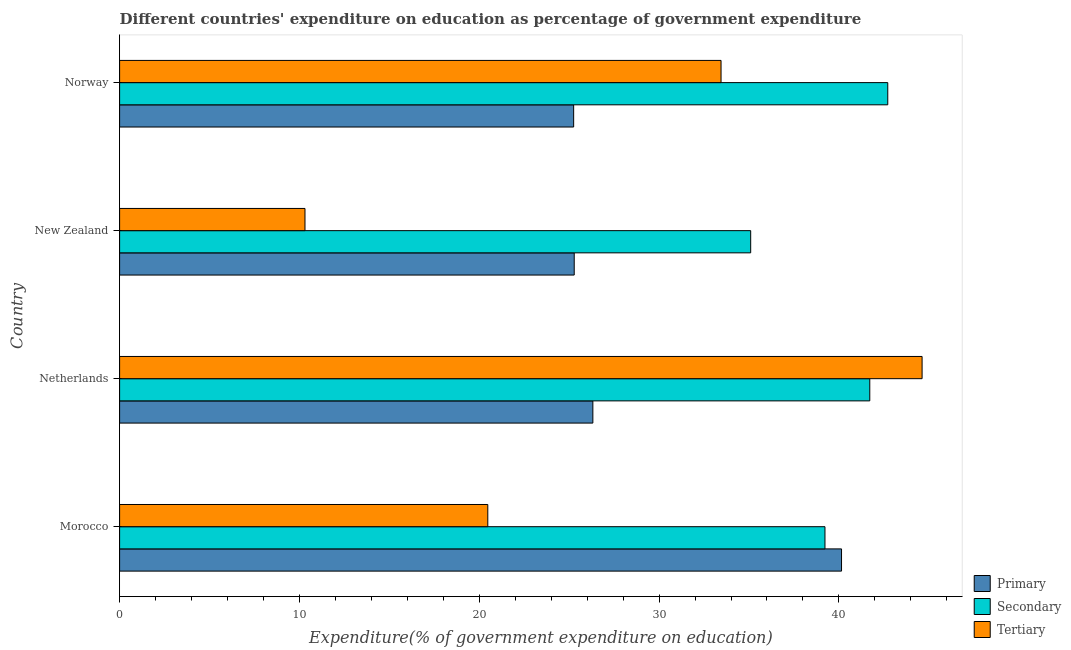How many different coloured bars are there?
Your answer should be compact. 3. Are the number of bars per tick equal to the number of legend labels?
Keep it short and to the point. Yes. Are the number of bars on each tick of the Y-axis equal?
Keep it short and to the point. Yes. How many bars are there on the 1st tick from the top?
Your answer should be very brief. 3. What is the label of the 2nd group of bars from the top?
Provide a succinct answer. New Zealand. What is the expenditure on tertiary education in Netherlands?
Provide a short and direct response. 44.63. Across all countries, what is the maximum expenditure on primary education?
Keep it short and to the point. 40.15. Across all countries, what is the minimum expenditure on tertiary education?
Your answer should be very brief. 10.31. In which country was the expenditure on tertiary education maximum?
Provide a succinct answer. Netherlands. In which country was the expenditure on secondary education minimum?
Keep it short and to the point. New Zealand. What is the total expenditure on tertiary education in the graph?
Ensure brevity in your answer.  108.85. What is the difference between the expenditure on primary education in Morocco and that in Norway?
Ensure brevity in your answer.  14.9. What is the difference between the expenditure on primary education in Morocco and the expenditure on secondary education in New Zealand?
Ensure brevity in your answer.  5.05. What is the average expenditure on secondary education per country?
Your response must be concise. 39.69. What is the difference between the expenditure on primary education and expenditure on tertiary education in New Zealand?
Make the answer very short. 14.97. In how many countries, is the expenditure on tertiary education greater than 10 %?
Your response must be concise. 4. What is the ratio of the expenditure on primary education in New Zealand to that in Norway?
Offer a very short reply. 1. Is the expenditure on tertiary education in Netherlands less than that in New Zealand?
Make the answer very short. No. Is the difference between the expenditure on secondary education in Netherlands and Norway greater than the difference between the expenditure on tertiary education in Netherlands and Norway?
Give a very brief answer. No. What is the difference between the highest and the second highest expenditure on tertiary education?
Give a very brief answer. 11.18. What is the difference between the highest and the lowest expenditure on primary education?
Your answer should be compact. 14.9. Is the sum of the expenditure on tertiary education in New Zealand and Norway greater than the maximum expenditure on secondary education across all countries?
Keep it short and to the point. Yes. What does the 2nd bar from the top in Norway represents?
Offer a very short reply. Secondary. What does the 2nd bar from the bottom in Morocco represents?
Your response must be concise. Secondary. How many countries are there in the graph?
Your answer should be very brief. 4. Does the graph contain any zero values?
Ensure brevity in your answer.  No. How many legend labels are there?
Keep it short and to the point. 3. What is the title of the graph?
Your response must be concise. Different countries' expenditure on education as percentage of government expenditure. Does "Total employers" appear as one of the legend labels in the graph?
Give a very brief answer. No. What is the label or title of the X-axis?
Your answer should be very brief. Expenditure(% of government expenditure on education). What is the Expenditure(% of government expenditure on education) in Primary in Morocco?
Keep it short and to the point. 40.15. What is the Expenditure(% of government expenditure on education) of Secondary in Morocco?
Give a very brief answer. 39.22. What is the Expenditure(% of government expenditure on education) in Tertiary in Morocco?
Your response must be concise. 20.47. What is the Expenditure(% of government expenditure on education) in Primary in Netherlands?
Give a very brief answer. 26.32. What is the Expenditure(% of government expenditure on education) in Secondary in Netherlands?
Offer a terse response. 41.72. What is the Expenditure(% of government expenditure on education) in Tertiary in Netherlands?
Make the answer very short. 44.63. What is the Expenditure(% of government expenditure on education) in Primary in New Zealand?
Offer a very short reply. 25.28. What is the Expenditure(% of government expenditure on education) of Secondary in New Zealand?
Keep it short and to the point. 35.09. What is the Expenditure(% of government expenditure on education) in Tertiary in New Zealand?
Provide a short and direct response. 10.31. What is the Expenditure(% of government expenditure on education) of Primary in Norway?
Give a very brief answer. 25.25. What is the Expenditure(% of government expenditure on education) of Secondary in Norway?
Your response must be concise. 42.72. What is the Expenditure(% of government expenditure on education) of Tertiary in Norway?
Ensure brevity in your answer.  33.45. Across all countries, what is the maximum Expenditure(% of government expenditure on education) in Primary?
Provide a short and direct response. 40.15. Across all countries, what is the maximum Expenditure(% of government expenditure on education) of Secondary?
Your response must be concise. 42.72. Across all countries, what is the maximum Expenditure(% of government expenditure on education) in Tertiary?
Your answer should be very brief. 44.63. Across all countries, what is the minimum Expenditure(% of government expenditure on education) in Primary?
Offer a very short reply. 25.25. Across all countries, what is the minimum Expenditure(% of government expenditure on education) of Secondary?
Offer a very short reply. 35.09. Across all countries, what is the minimum Expenditure(% of government expenditure on education) of Tertiary?
Offer a very short reply. 10.31. What is the total Expenditure(% of government expenditure on education) in Primary in the graph?
Your response must be concise. 116.99. What is the total Expenditure(% of government expenditure on education) in Secondary in the graph?
Offer a very short reply. 158.75. What is the total Expenditure(% of government expenditure on education) of Tertiary in the graph?
Your answer should be very brief. 108.85. What is the difference between the Expenditure(% of government expenditure on education) of Primary in Morocco and that in Netherlands?
Your answer should be compact. 13.83. What is the difference between the Expenditure(% of government expenditure on education) of Secondary in Morocco and that in Netherlands?
Provide a short and direct response. -2.49. What is the difference between the Expenditure(% of government expenditure on education) in Tertiary in Morocco and that in Netherlands?
Keep it short and to the point. -24.15. What is the difference between the Expenditure(% of government expenditure on education) in Primary in Morocco and that in New Zealand?
Give a very brief answer. 14.87. What is the difference between the Expenditure(% of government expenditure on education) in Secondary in Morocco and that in New Zealand?
Give a very brief answer. 4.13. What is the difference between the Expenditure(% of government expenditure on education) of Tertiary in Morocco and that in New Zealand?
Give a very brief answer. 10.17. What is the difference between the Expenditure(% of government expenditure on education) of Primary in Morocco and that in Norway?
Ensure brevity in your answer.  14.9. What is the difference between the Expenditure(% of government expenditure on education) of Secondary in Morocco and that in Norway?
Provide a succinct answer. -3.49. What is the difference between the Expenditure(% of government expenditure on education) in Tertiary in Morocco and that in Norway?
Provide a succinct answer. -12.97. What is the difference between the Expenditure(% of government expenditure on education) in Primary in Netherlands and that in New Zealand?
Provide a succinct answer. 1.04. What is the difference between the Expenditure(% of government expenditure on education) of Secondary in Netherlands and that in New Zealand?
Your answer should be very brief. 6.62. What is the difference between the Expenditure(% of government expenditure on education) of Tertiary in Netherlands and that in New Zealand?
Offer a terse response. 34.32. What is the difference between the Expenditure(% of government expenditure on education) of Primary in Netherlands and that in Norway?
Offer a very short reply. 1.07. What is the difference between the Expenditure(% of government expenditure on education) in Secondary in Netherlands and that in Norway?
Provide a succinct answer. -1. What is the difference between the Expenditure(% of government expenditure on education) in Tertiary in Netherlands and that in Norway?
Provide a succinct answer. 11.18. What is the difference between the Expenditure(% of government expenditure on education) in Primary in New Zealand and that in Norway?
Your response must be concise. 0.03. What is the difference between the Expenditure(% of government expenditure on education) in Secondary in New Zealand and that in Norway?
Your response must be concise. -7.62. What is the difference between the Expenditure(% of government expenditure on education) in Tertiary in New Zealand and that in Norway?
Offer a very short reply. -23.14. What is the difference between the Expenditure(% of government expenditure on education) in Primary in Morocco and the Expenditure(% of government expenditure on education) in Secondary in Netherlands?
Ensure brevity in your answer.  -1.57. What is the difference between the Expenditure(% of government expenditure on education) in Primary in Morocco and the Expenditure(% of government expenditure on education) in Tertiary in Netherlands?
Your answer should be compact. -4.48. What is the difference between the Expenditure(% of government expenditure on education) of Secondary in Morocco and the Expenditure(% of government expenditure on education) of Tertiary in Netherlands?
Your answer should be compact. -5.4. What is the difference between the Expenditure(% of government expenditure on education) of Primary in Morocco and the Expenditure(% of government expenditure on education) of Secondary in New Zealand?
Keep it short and to the point. 5.05. What is the difference between the Expenditure(% of government expenditure on education) in Primary in Morocco and the Expenditure(% of government expenditure on education) in Tertiary in New Zealand?
Offer a terse response. 29.84. What is the difference between the Expenditure(% of government expenditure on education) of Secondary in Morocco and the Expenditure(% of government expenditure on education) of Tertiary in New Zealand?
Your answer should be very brief. 28.92. What is the difference between the Expenditure(% of government expenditure on education) in Primary in Morocco and the Expenditure(% of government expenditure on education) in Secondary in Norway?
Make the answer very short. -2.57. What is the difference between the Expenditure(% of government expenditure on education) of Primary in Morocco and the Expenditure(% of government expenditure on education) of Tertiary in Norway?
Offer a terse response. 6.7. What is the difference between the Expenditure(% of government expenditure on education) in Secondary in Morocco and the Expenditure(% of government expenditure on education) in Tertiary in Norway?
Offer a very short reply. 5.78. What is the difference between the Expenditure(% of government expenditure on education) of Primary in Netherlands and the Expenditure(% of government expenditure on education) of Secondary in New Zealand?
Give a very brief answer. -8.78. What is the difference between the Expenditure(% of government expenditure on education) of Primary in Netherlands and the Expenditure(% of government expenditure on education) of Tertiary in New Zealand?
Keep it short and to the point. 16.01. What is the difference between the Expenditure(% of government expenditure on education) in Secondary in Netherlands and the Expenditure(% of government expenditure on education) in Tertiary in New Zealand?
Your answer should be compact. 31.41. What is the difference between the Expenditure(% of government expenditure on education) in Primary in Netherlands and the Expenditure(% of government expenditure on education) in Secondary in Norway?
Make the answer very short. -16.4. What is the difference between the Expenditure(% of government expenditure on education) of Primary in Netherlands and the Expenditure(% of government expenditure on education) of Tertiary in Norway?
Make the answer very short. -7.13. What is the difference between the Expenditure(% of government expenditure on education) in Secondary in Netherlands and the Expenditure(% of government expenditure on education) in Tertiary in Norway?
Give a very brief answer. 8.27. What is the difference between the Expenditure(% of government expenditure on education) of Primary in New Zealand and the Expenditure(% of government expenditure on education) of Secondary in Norway?
Keep it short and to the point. -17.44. What is the difference between the Expenditure(% of government expenditure on education) of Primary in New Zealand and the Expenditure(% of government expenditure on education) of Tertiary in Norway?
Offer a very short reply. -8.16. What is the difference between the Expenditure(% of government expenditure on education) of Secondary in New Zealand and the Expenditure(% of government expenditure on education) of Tertiary in Norway?
Offer a terse response. 1.65. What is the average Expenditure(% of government expenditure on education) of Primary per country?
Offer a very short reply. 29.25. What is the average Expenditure(% of government expenditure on education) of Secondary per country?
Provide a succinct answer. 39.69. What is the average Expenditure(% of government expenditure on education) in Tertiary per country?
Give a very brief answer. 27.21. What is the difference between the Expenditure(% of government expenditure on education) in Primary and Expenditure(% of government expenditure on education) in Secondary in Morocco?
Ensure brevity in your answer.  0.92. What is the difference between the Expenditure(% of government expenditure on education) in Primary and Expenditure(% of government expenditure on education) in Tertiary in Morocco?
Make the answer very short. 19.67. What is the difference between the Expenditure(% of government expenditure on education) of Secondary and Expenditure(% of government expenditure on education) of Tertiary in Morocco?
Make the answer very short. 18.75. What is the difference between the Expenditure(% of government expenditure on education) in Primary and Expenditure(% of government expenditure on education) in Secondary in Netherlands?
Provide a succinct answer. -15.4. What is the difference between the Expenditure(% of government expenditure on education) in Primary and Expenditure(% of government expenditure on education) in Tertiary in Netherlands?
Make the answer very short. -18.31. What is the difference between the Expenditure(% of government expenditure on education) in Secondary and Expenditure(% of government expenditure on education) in Tertiary in Netherlands?
Offer a very short reply. -2.91. What is the difference between the Expenditure(% of government expenditure on education) in Primary and Expenditure(% of government expenditure on education) in Secondary in New Zealand?
Provide a succinct answer. -9.81. What is the difference between the Expenditure(% of government expenditure on education) in Primary and Expenditure(% of government expenditure on education) in Tertiary in New Zealand?
Offer a very short reply. 14.97. What is the difference between the Expenditure(% of government expenditure on education) in Secondary and Expenditure(% of government expenditure on education) in Tertiary in New Zealand?
Keep it short and to the point. 24.78. What is the difference between the Expenditure(% of government expenditure on education) of Primary and Expenditure(% of government expenditure on education) of Secondary in Norway?
Offer a very short reply. -17.47. What is the difference between the Expenditure(% of government expenditure on education) of Primary and Expenditure(% of government expenditure on education) of Tertiary in Norway?
Provide a succinct answer. -8.2. What is the difference between the Expenditure(% of government expenditure on education) of Secondary and Expenditure(% of government expenditure on education) of Tertiary in Norway?
Provide a short and direct response. 9.27. What is the ratio of the Expenditure(% of government expenditure on education) of Primary in Morocco to that in Netherlands?
Your answer should be very brief. 1.53. What is the ratio of the Expenditure(% of government expenditure on education) of Secondary in Morocco to that in Netherlands?
Provide a short and direct response. 0.94. What is the ratio of the Expenditure(% of government expenditure on education) in Tertiary in Morocco to that in Netherlands?
Your response must be concise. 0.46. What is the ratio of the Expenditure(% of government expenditure on education) of Primary in Morocco to that in New Zealand?
Keep it short and to the point. 1.59. What is the ratio of the Expenditure(% of government expenditure on education) of Secondary in Morocco to that in New Zealand?
Your response must be concise. 1.12. What is the ratio of the Expenditure(% of government expenditure on education) of Tertiary in Morocco to that in New Zealand?
Provide a succinct answer. 1.99. What is the ratio of the Expenditure(% of government expenditure on education) in Primary in Morocco to that in Norway?
Keep it short and to the point. 1.59. What is the ratio of the Expenditure(% of government expenditure on education) in Secondary in Morocco to that in Norway?
Your answer should be compact. 0.92. What is the ratio of the Expenditure(% of government expenditure on education) of Tertiary in Morocco to that in Norway?
Your answer should be very brief. 0.61. What is the ratio of the Expenditure(% of government expenditure on education) of Primary in Netherlands to that in New Zealand?
Your response must be concise. 1.04. What is the ratio of the Expenditure(% of government expenditure on education) in Secondary in Netherlands to that in New Zealand?
Ensure brevity in your answer.  1.19. What is the ratio of the Expenditure(% of government expenditure on education) in Tertiary in Netherlands to that in New Zealand?
Offer a very short reply. 4.33. What is the ratio of the Expenditure(% of government expenditure on education) in Primary in Netherlands to that in Norway?
Your response must be concise. 1.04. What is the ratio of the Expenditure(% of government expenditure on education) of Secondary in Netherlands to that in Norway?
Offer a terse response. 0.98. What is the ratio of the Expenditure(% of government expenditure on education) of Tertiary in Netherlands to that in Norway?
Your response must be concise. 1.33. What is the ratio of the Expenditure(% of government expenditure on education) in Primary in New Zealand to that in Norway?
Offer a terse response. 1. What is the ratio of the Expenditure(% of government expenditure on education) of Secondary in New Zealand to that in Norway?
Offer a very short reply. 0.82. What is the ratio of the Expenditure(% of government expenditure on education) in Tertiary in New Zealand to that in Norway?
Give a very brief answer. 0.31. What is the difference between the highest and the second highest Expenditure(% of government expenditure on education) of Primary?
Offer a very short reply. 13.83. What is the difference between the highest and the second highest Expenditure(% of government expenditure on education) in Tertiary?
Provide a succinct answer. 11.18. What is the difference between the highest and the lowest Expenditure(% of government expenditure on education) in Primary?
Give a very brief answer. 14.9. What is the difference between the highest and the lowest Expenditure(% of government expenditure on education) in Secondary?
Give a very brief answer. 7.62. What is the difference between the highest and the lowest Expenditure(% of government expenditure on education) in Tertiary?
Make the answer very short. 34.32. 